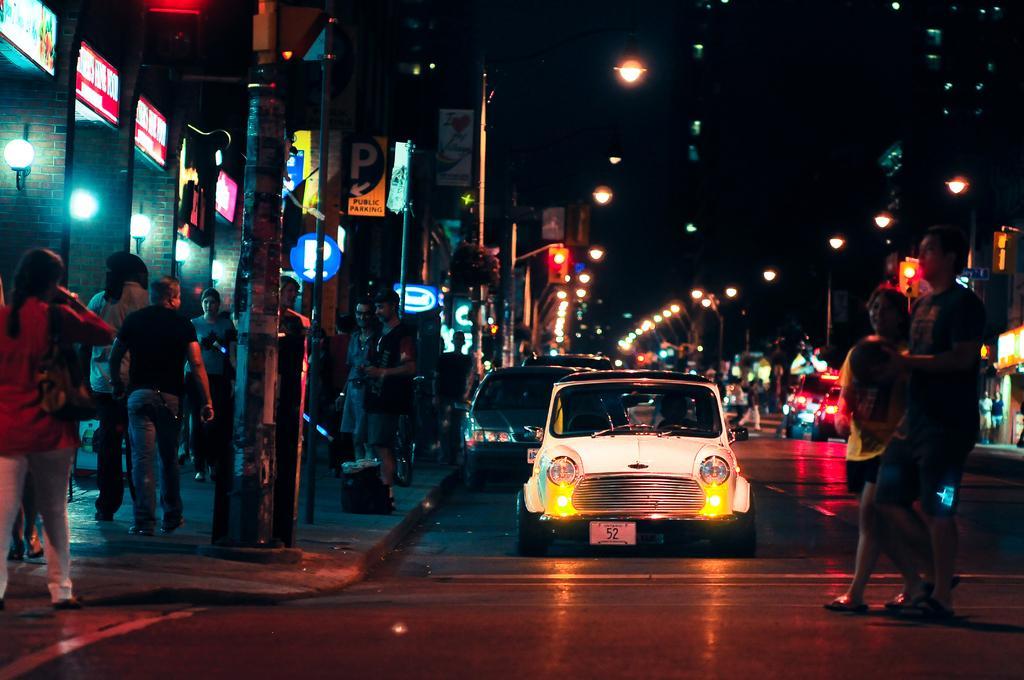How would you summarize this image in a sentence or two? In this picture I can see vehicles on the road, there are group of people, lights, boards, poles, buildings. 